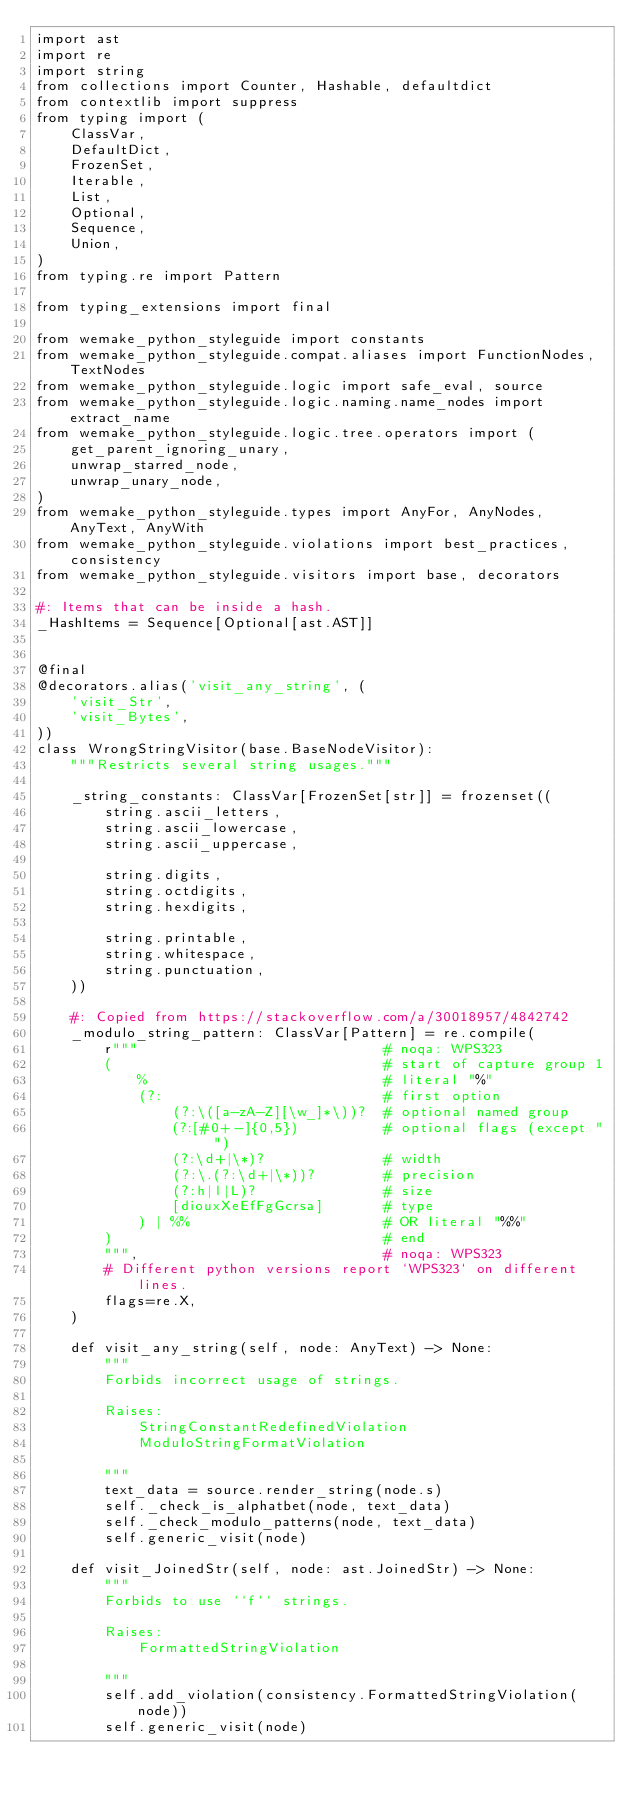Convert code to text. <code><loc_0><loc_0><loc_500><loc_500><_Python_>import ast
import re
import string
from collections import Counter, Hashable, defaultdict
from contextlib import suppress
from typing import (
    ClassVar,
    DefaultDict,
    FrozenSet,
    Iterable,
    List,
    Optional,
    Sequence,
    Union,
)
from typing.re import Pattern

from typing_extensions import final

from wemake_python_styleguide import constants
from wemake_python_styleguide.compat.aliases import FunctionNodes, TextNodes
from wemake_python_styleguide.logic import safe_eval, source
from wemake_python_styleguide.logic.naming.name_nodes import extract_name
from wemake_python_styleguide.logic.tree.operators import (
    get_parent_ignoring_unary,
    unwrap_starred_node,
    unwrap_unary_node,
)
from wemake_python_styleguide.types import AnyFor, AnyNodes, AnyText, AnyWith
from wemake_python_styleguide.violations import best_practices, consistency
from wemake_python_styleguide.visitors import base, decorators

#: Items that can be inside a hash.
_HashItems = Sequence[Optional[ast.AST]]


@final
@decorators.alias('visit_any_string', (
    'visit_Str',
    'visit_Bytes',
))
class WrongStringVisitor(base.BaseNodeVisitor):
    """Restricts several string usages."""

    _string_constants: ClassVar[FrozenSet[str]] = frozenset((
        string.ascii_letters,
        string.ascii_lowercase,
        string.ascii_uppercase,

        string.digits,
        string.octdigits,
        string.hexdigits,

        string.printable,
        string.whitespace,
        string.punctuation,
    ))

    #: Copied from https://stackoverflow.com/a/30018957/4842742
    _modulo_string_pattern: ClassVar[Pattern] = re.compile(
        r"""                             # noqa: WPS323
        (                                # start of capture group 1
            %                            # literal "%"
            (?:                          # first option
                (?:\([a-zA-Z][\w_]*\))?  # optional named group
                (?:[#0+-]{0,5})          # optional flags (except " ")
                (?:\d+|\*)?              # width
                (?:\.(?:\d+|\*))?        # precision
                (?:h|l|L)?               # size
                [diouxXeEfFgGcrsa]       # type
            ) | %%                       # OR literal "%%"
        )                                # end
        """,                             # noqa: WPS323
        # Different python versions report `WPS323` on different lines.
        flags=re.X,
    )

    def visit_any_string(self, node: AnyText) -> None:
        """
        Forbids incorrect usage of strings.

        Raises:
            StringConstantRedefinedViolation
            ModuloStringFormatViolation

        """
        text_data = source.render_string(node.s)
        self._check_is_alphatbet(node, text_data)
        self._check_modulo_patterns(node, text_data)
        self.generic_visit(node)

    def visit_JoinedStr(self, node: ast.JoinedStr) -> None:
        """
        Forbids to use ``f`` strings.

        Raises:
            FormattedStringViolation

        """
        self.add_violation(consistency.FormattedStringViolation(node))
        self.generic_visit(node)
</code> 